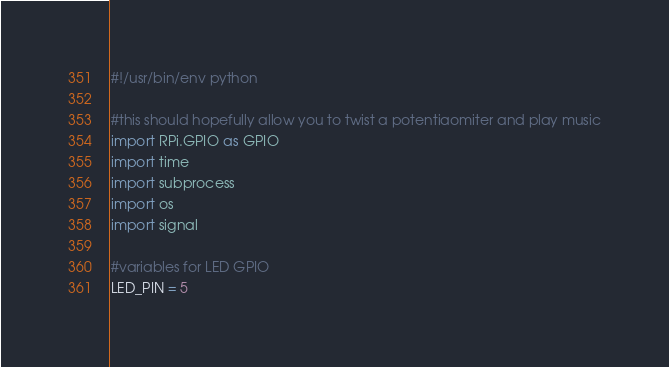Convert code to text. <code><loc_0><loc_0><loc_500><loc_500><_Python_>#!/usr/bin/env python

#this should hopefully allow you to twist a potentiaomiter and play music
import RPi.GPIO as GPIO
import time
import subprocess
import os
import signal

#variables for LED GPIO
LED_PIN = 5</code> 